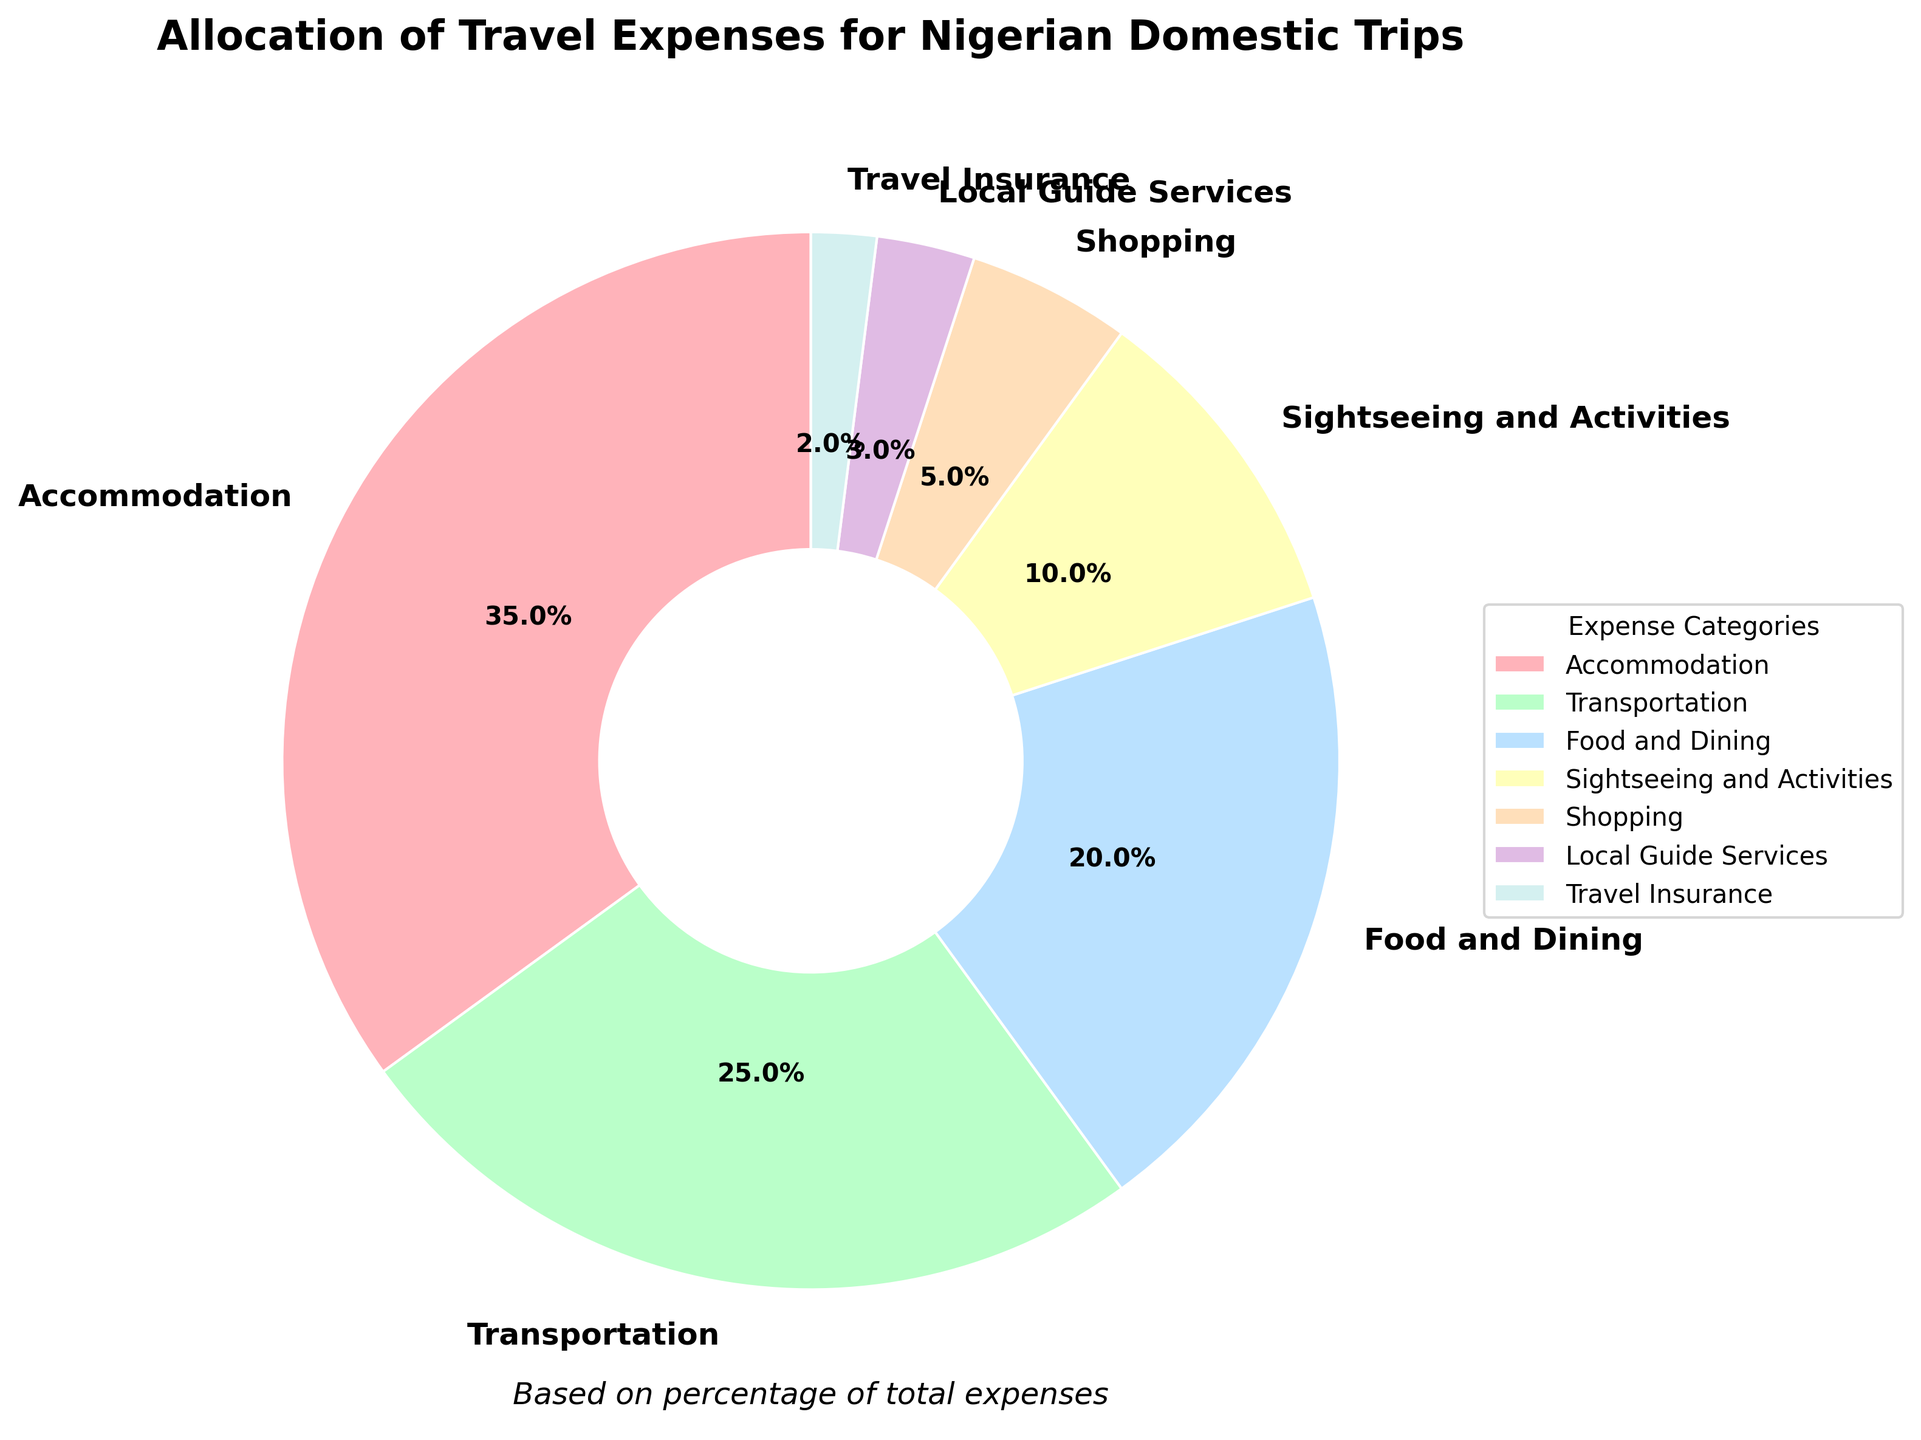What's the largest expense category for Nigerian domestic trips? The largest expense category can be identified based on the largest segment in the pie chart. The category with the highest percentage is Accommodation, which occupies 35% of the total expenses.
Answer: Accommodation What is the total percentage of expenses for Transportation and Food and Dining combined? To find the total percentage for Transportation and Food and Dining, add the percentages of both categories. Transportation is 25% and Food and Dining is 20%. Therefore, the total is 25% + 20% = 45%.
Answer: 45% Which category has a smaller percentage: Shopping or Local Guide Services? By comparing the percentages for Shopping and Local Guide Services from the pie chart, Shopping has 5% and Local Guide Services has 3%. Therefore, Local Guide Services is smaller.
Answer: Local Guide Services How much more is spent on Sightseeing and Activities compared to Travel Insurance? To determine the difference in spending between Sightseeing and Activities and Travel Insurance, subtract the percentage of Travel Insurance from Sightseeing and Activities. Sightseeing and Activities is 10%, and Travel Insurance is 2%, so the difference is 10% - 2% = 8%.
Answer: 8% If expenses for Accommodation were reduced by 10%, what would be the new percentage? First, calculate 10% of the Accommodation expense, which is 10% of 35% (0.10 * 35 = 3.5). Then subtract that from the original percentage: 35% - 3.5% = 31.5%.
Answer: 31.5% What is the combined percentage of the three smallest categories? First, identify the three smallest categories: Travel Insurance (2%), Local Guide Services (3%), and Shopping (5%). Add these percentages together: 2% + 3% + 5% = 10%.
Answer: 10% Which category is represented by the pinkish wedge in the chart? The pinkish wedge in the chart represents the Accommodation category. As the largest segment, it is typically displayed prominently in the pie chart.
Answer: Accommodation Is the percentage spent on Shopping greater than the sum of Local Guide Services and Travel Insurance? Calculate the sum of Local Guide Services and Travel Insurance: 3% + 2% = 5%. The percentage for Shopping is also 5%. Thus, the percentage spent on Shopping is equal to the sum of Local Guide Services and Travel Insurance.
Answer: No 